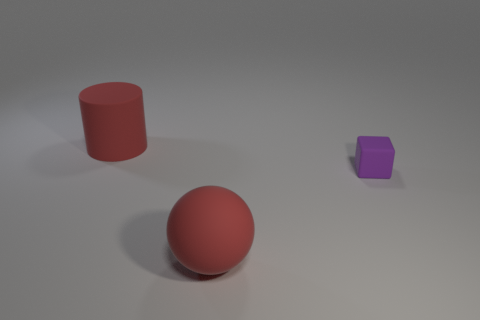Add 3 matte cubes. How many objects exist? 6 Subtract all spheres. How many objects are left? 2 Subtract 1 purple blocks. How many objects are left? 2 Subtract all balls. Subtract all matte cylinders. How many objects are left? 1 Add 3 large matte objects. How many large matte objects are left? 5 Add 1 cyan matte balls. How many cyan matte balls exist? 1 